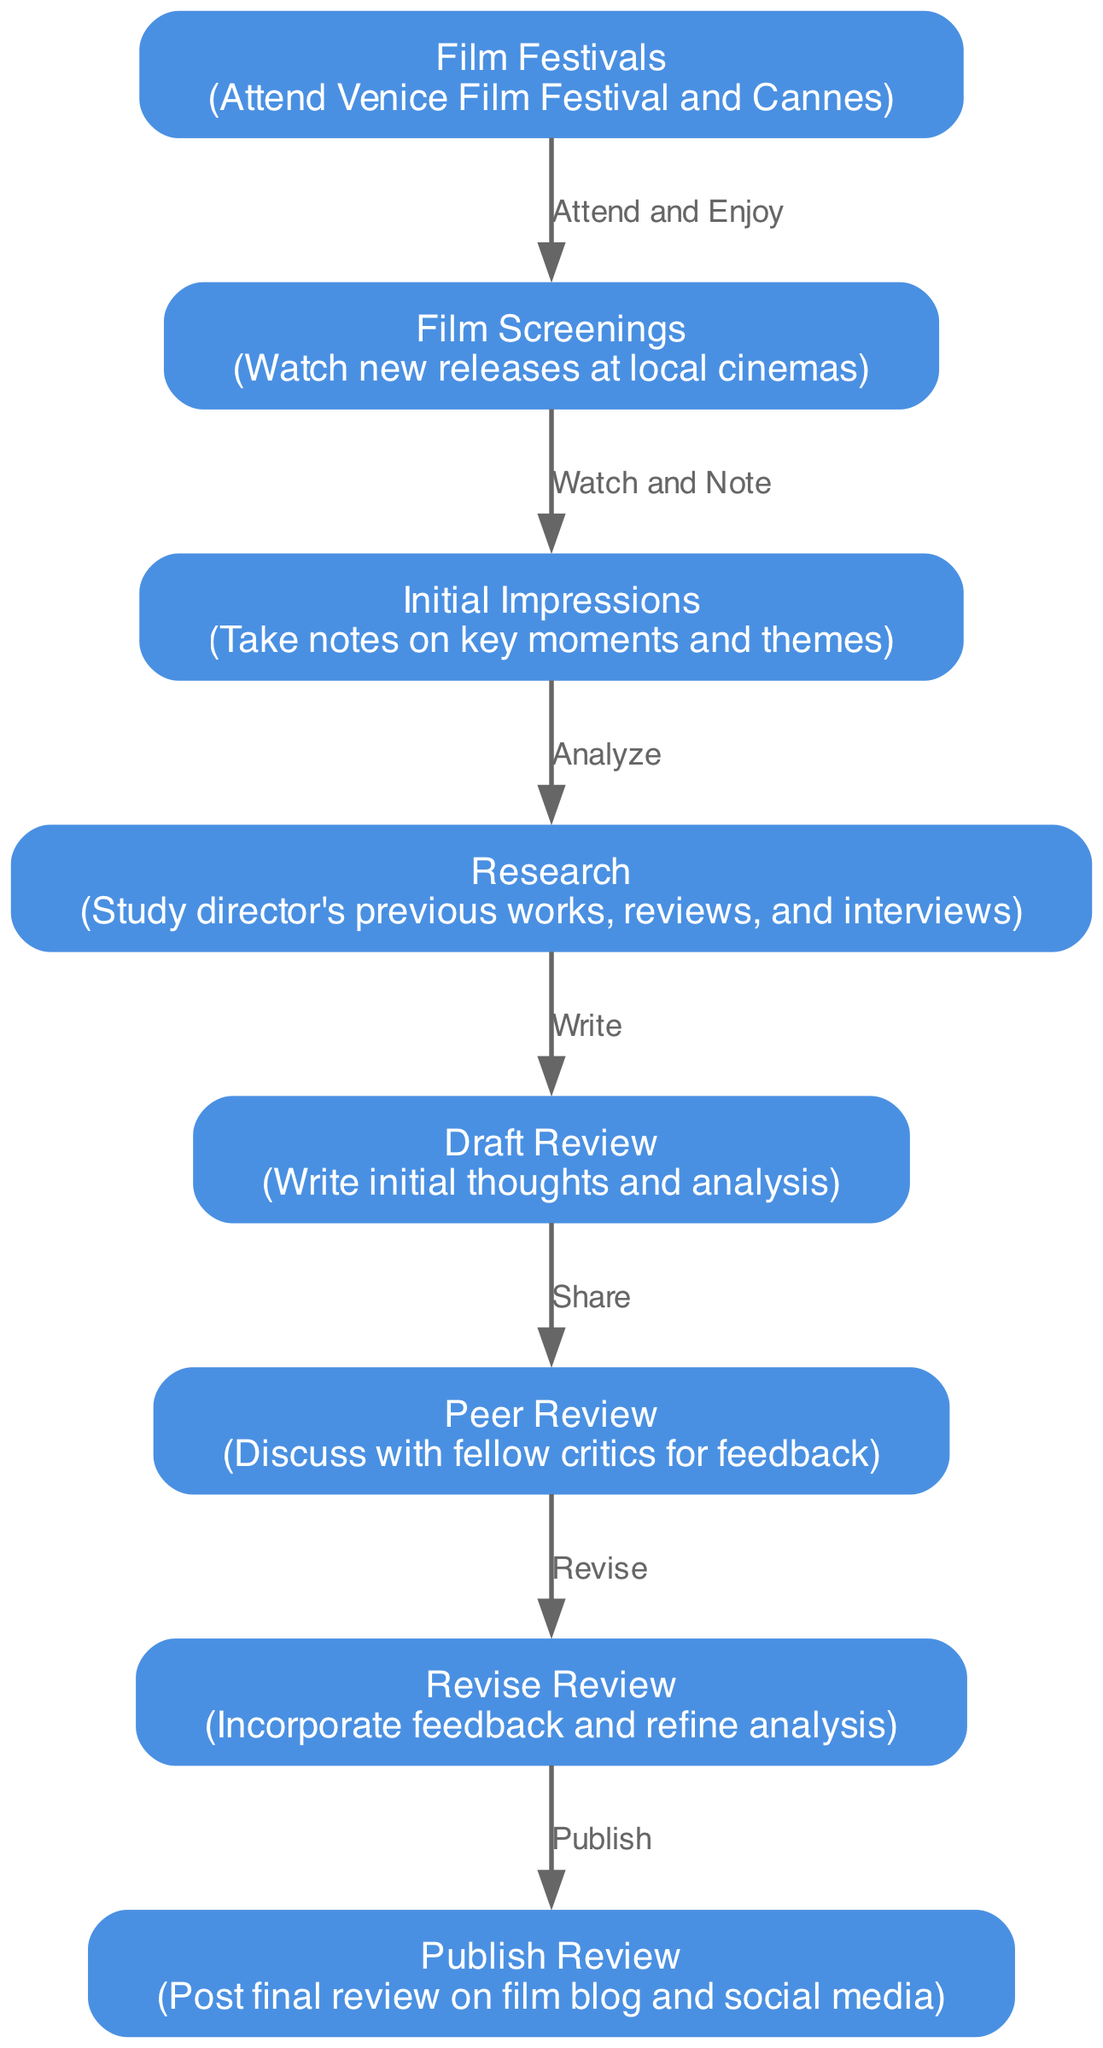What is the first step in the workflow? The first step is represented by the node labeled "Film Festivals", which states to attend Venice Film Festival and Cannes. It is the starting point of the entire workflow.
Answer: Film Festivals How many nodes are there in the diagram? Counting all the distinct nodes listed in the diagram, there are a total of eight nodes, each representing a specific stage in the critic's workflow.
Answer: 8 What do you do after taking initial impressions? After taking initial impressions, the next step in the workflow is to conduct "Research" on the director's previous works, reviews, and interviews, as represented by the directional edge in the diagram.
Answer: Research Which nodes are connected by the edge labeled "Revise"? The edge labeled "Revise" connects the nodes "Peer Review" and "Revise Review", indicating the flow from discussing feedback to refining the analysis.
Answer: Peer Review and Revise Review What is the last step in the workflow? The last step in the workflow, as shown in the diagram, is to "Publish Review," which includes posting the final review on the film blog and social media.
Answer: Publish Review What is the relationship between "Draft Review" and "Peer Review"? The edge between "Draft Review" and "Peer Review" is labeled "Share," indicating that after drafting the review, the critic shares it with fellow critics for feedback.
Answer: Share Which node involves analyzing key moments and themes? The node labeled "Initial Impressions" involves taking notes and analyzing key moments and themes as the critic watches the films.
Answer: Initial Impressions What comes directly after the "Research" stage? Following the "Research" stage, the next step in the workflow is "Draft Review," where the critic writes initial thoughts and analysis based on their research and impressions.
Answer: Draft Review 